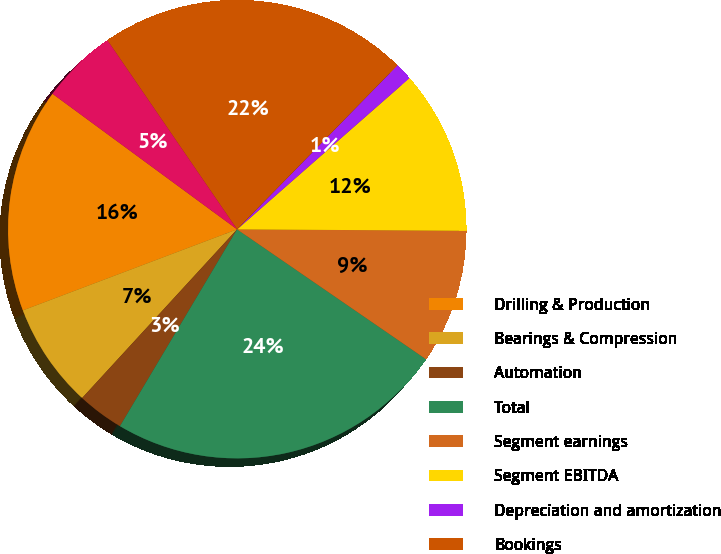<chart> <loc_0><loc_0><loc_500><loc_500><pie_chart><fcel>Drilling & Production<fcel>Bearings & Compression<fcel>Automation<fcel>Total<fcel>Segment earnings<fcel>Segment EBITDA<fcel>Depreciation and amortization<fcel>Bookings<fcel>Backlog<nl><fcel>15.84%<fcel>7.42%<fcel>3.28%<fcel>23.96%<fcel>9.49%<fcel>11.56%<fcel>1.22%<fcel>21.89%<fcel>5.35%<nl></chart> 